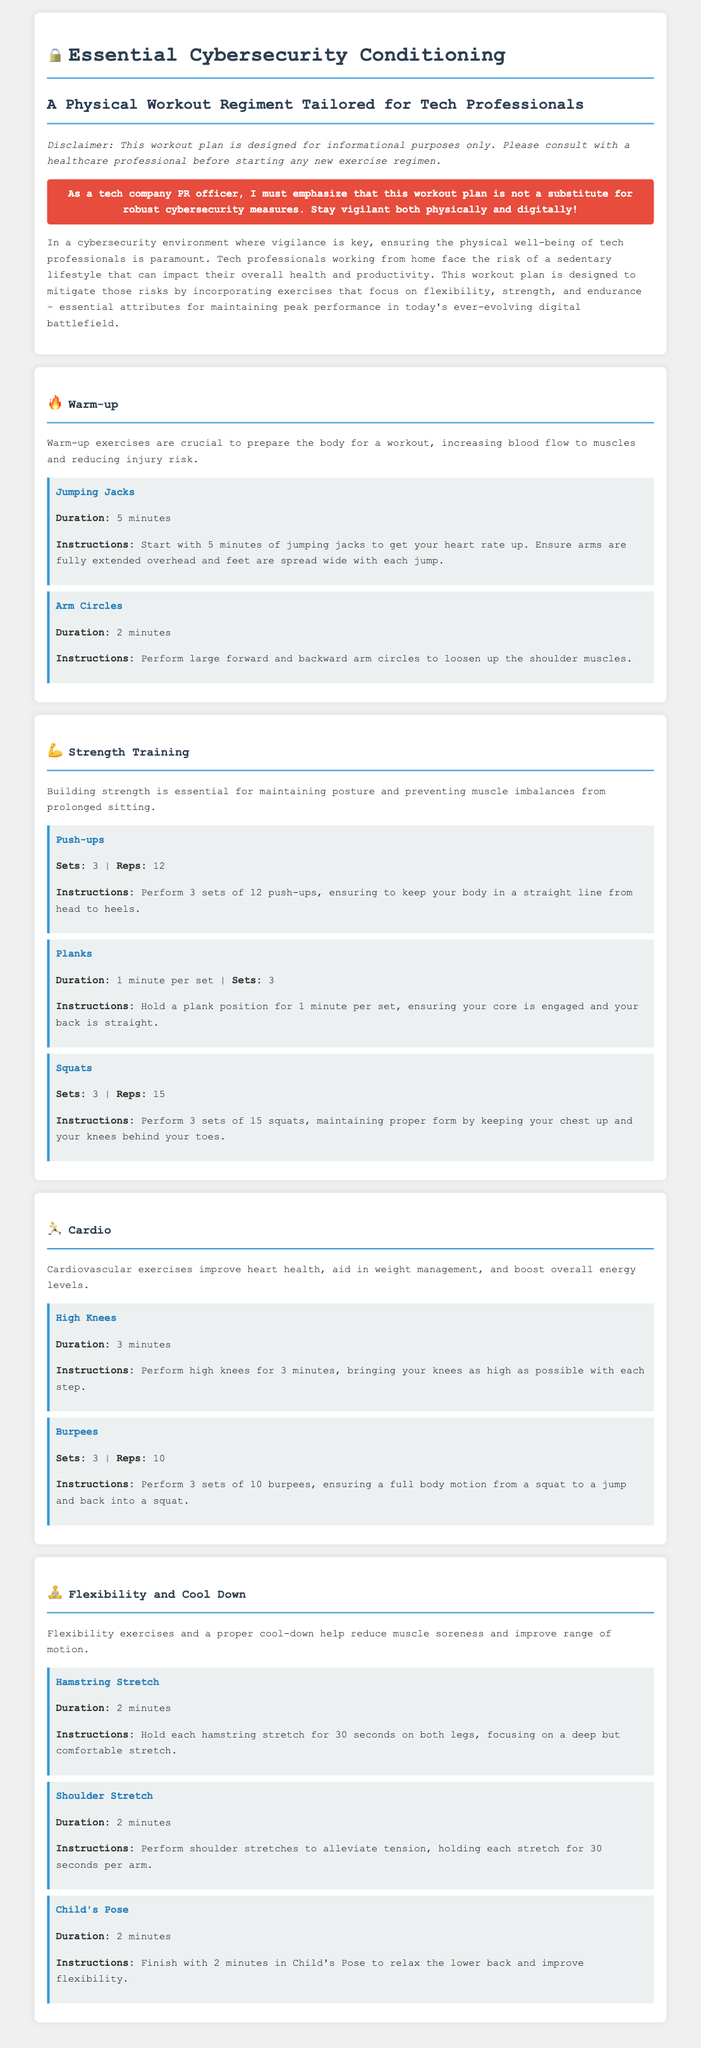What is the duration of Jumping Jacks? The duration for Jumping Jacks is specified in the workout plan as 5 minutes.
Answer: 5 minutes How many sets of Push-ups should be performed? The document states that 3 sets of Push-ups should be performed.
Answer: 3 sets What is the main purpose of the workout plan? The workout plan aims to mitigate the risks of a sedentary lifestyle for tech professionals working from home.
Answer: Mitigate sedentary lifestyle risks What type of activity follows Strength Training? The document outlines Cardio as the activity that follows Strength Training.
Answer: Cardio What flexibility exercise is included in the cool-down? The cool-down in the workout plan includes a Hamstring Stretch.
Answer: Hamstring Stretch How long should each Hamstring Stretch last? The document indicates that each Hamstring Stretch should be held for 30 seconds on both legs.
Answer: 30 seconds What is the recommended duration for High Knees? The plan specifies that High Knees should be performed for a duration of 3 minutes.
Answer: 3 minutes What is a key emphasis of the disclaimer in the document? The disclaimer highlights that the workout plan is not a substitute for robust cybersecurity measures.
Answer: Not a substitute for cybersecurity measures 